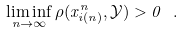Convert formula to latex. <formula><loc_0><loc_0><loc_500><loc_500>\liminf _ { n \rightarrow \infty } \rho ( x _ { i ( n ) } ^ { n } , { \mathcal { Y } } ) > 0 \ .</formula> 